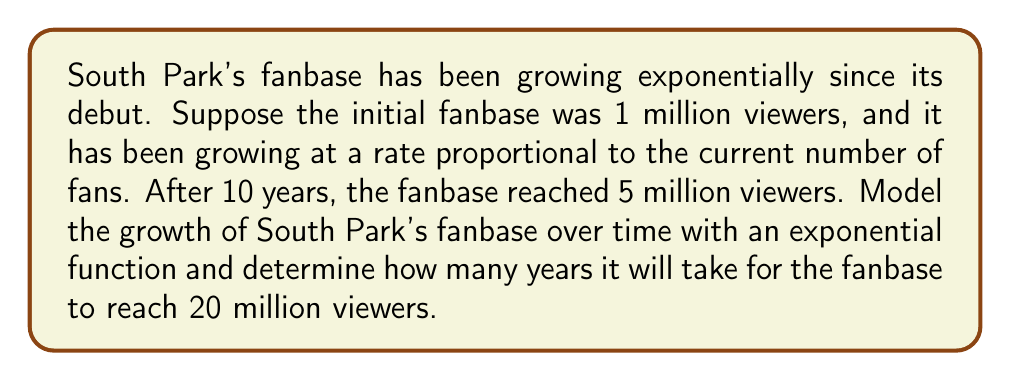Provide a solution to this math problem. Let's approach this step-by-step:

1) We can model the fanbase growth with the exponential function:

   $$ P(t) = P_0 e^{rt} $$

   where $P(t)$ is the number of fans at time $t$, $P_0$ is the initial number of fans, $r$ is the growth rate, and $t$ is time in years.

2) We know:
   - $P_0 = 1$ million (initial fanbase)
   - After 10 years, $P(10) = 5$ million

3) Let's substitute these values into our equation:

   $$ 5 = 1 \cdot e^{10r} $$

4) Solve for $r$:

   $$ 5 = e^{10r} $$
   $$ \ln(5) = 10r $$
   $$ r = \frac{\ln(5)}{10} \approx 0.1609 $$

5) Now our model is:

   $$ P(t) = 1 \cdot e^{0.1609t} $$

6) To find when the fanbase reaches 20 million, we solve:

   $$ 20 = 1 \cdot e^{0.1609t} $$
   $$ 20 = e^{0.1609t} $$
   $$ \ln(20) = 0.1609t $$
   $$ t = \frac{\ln(20)}{0.1609} \approx 18.66 $$
Answer: It will take approximately 18.66 years for South Park's fanbase to reach 20 million viewers. 